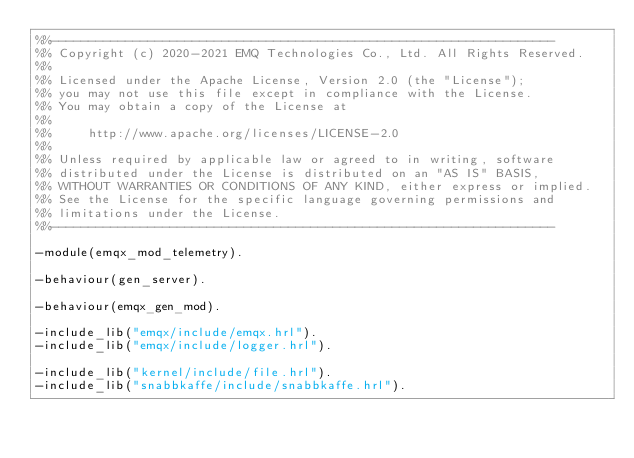Convert code to text. <code><loc_0><loc_0><loc_500><loc_500><_Erlang_>%%--------------------------------------------------------------------
%% Copyright (c) 2020-2021 EMQ Technologies Co., Ltd. All Rights Reserved.
%%
%% Licensed under the Apache License, Version 2.0 (the "License");
%% you may not use this file except in compliance with the License.
%% You may obtain a copy of the License at
%%
%%     http://www.apache.org/licenses/LICENSE-2.0
%%
%% Unless required by applicable law or agreed to in writing, software
%% distributed under the License is distributed on an "AS IS" BASIS,
%% WITHOUT WARRANTIES OR CONDITIONS OF ANY KIND, either express or implied.
%% See the License for the specific language governing permissions and
%% limitations under the License.
%%--------------------------------------------------------------------

-module(emqx_mod_telemetry).

-behaviour(gen_server).

-behaviour(emqx_gen_mod).

-include_lib("emqx/include/emqx.hrl").
-include_lib("emqx/include/logger.hrl").

-include_lib("kernel/include/file.hrl").
-include_lib("snabbkaffe/include/snabbkaffe.hrl").
</code> 